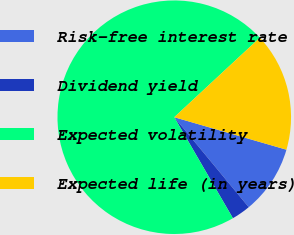Convert chart. <chart><loc_0><loc_0><loc_500><loc_500><pie_chart><fcel>Risk-free interest rate<fcel>Dividend yield<fcel>Expected volatility<fcel>Expected life (in years)<nl><fcel>9.51%<fcel>2.63%<fcel>71.46%<fcel>16.4%<nl></chart> 